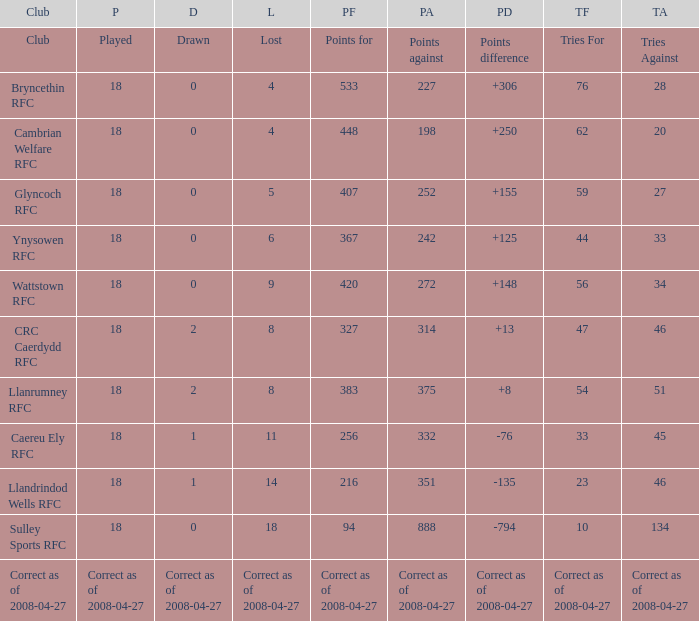What is the value for the item "Tries" when the value of the item "Played" is 18 and the value of the item "Points" is 375? 54.0. 